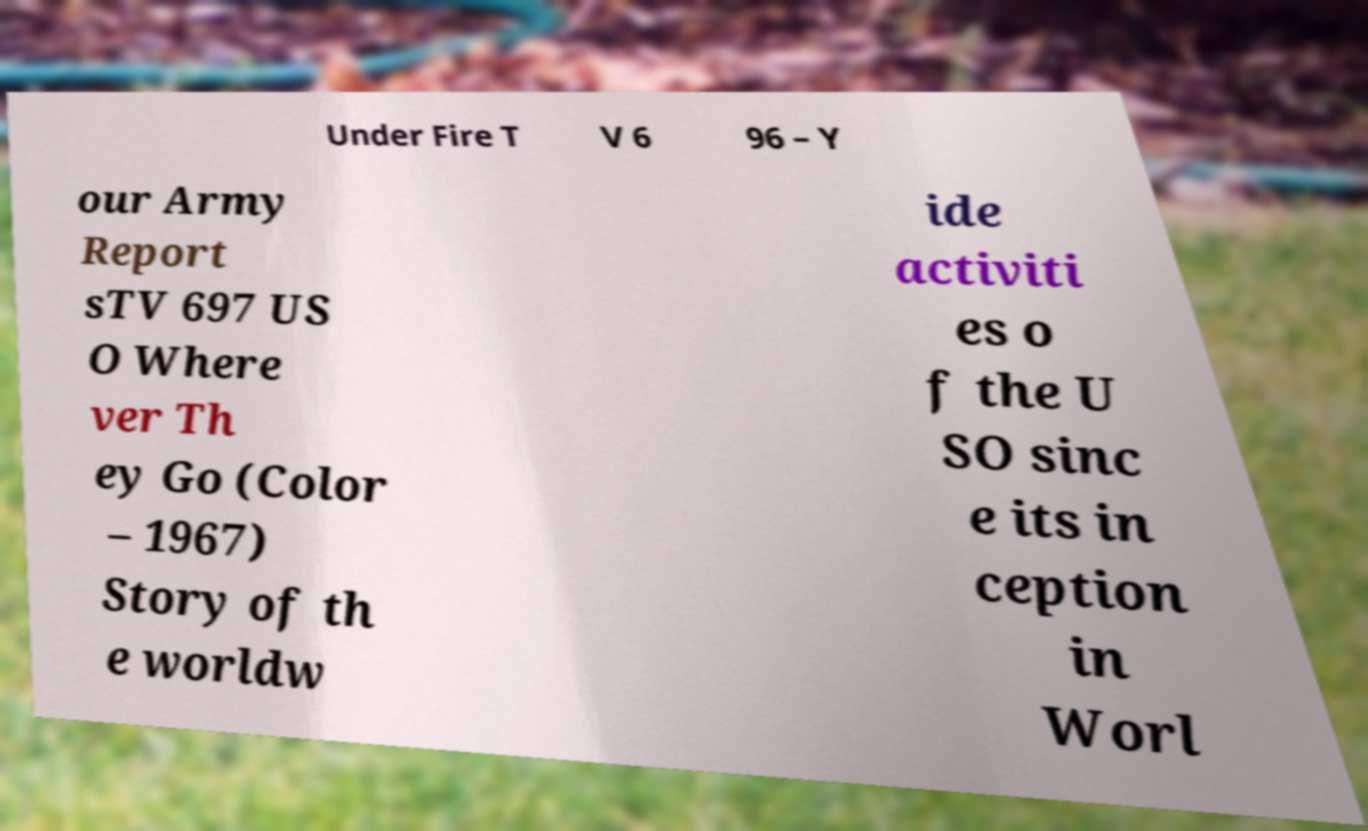Please read and relay the text visible in this image. What does it say? Under Fire T V 6 96 – Y our Army Report sTV 697 US O Where ver Th ey Go (Color – 1967) Story of th e worldw ide activiti es o f the U SO sinc e its in ception in Worl 